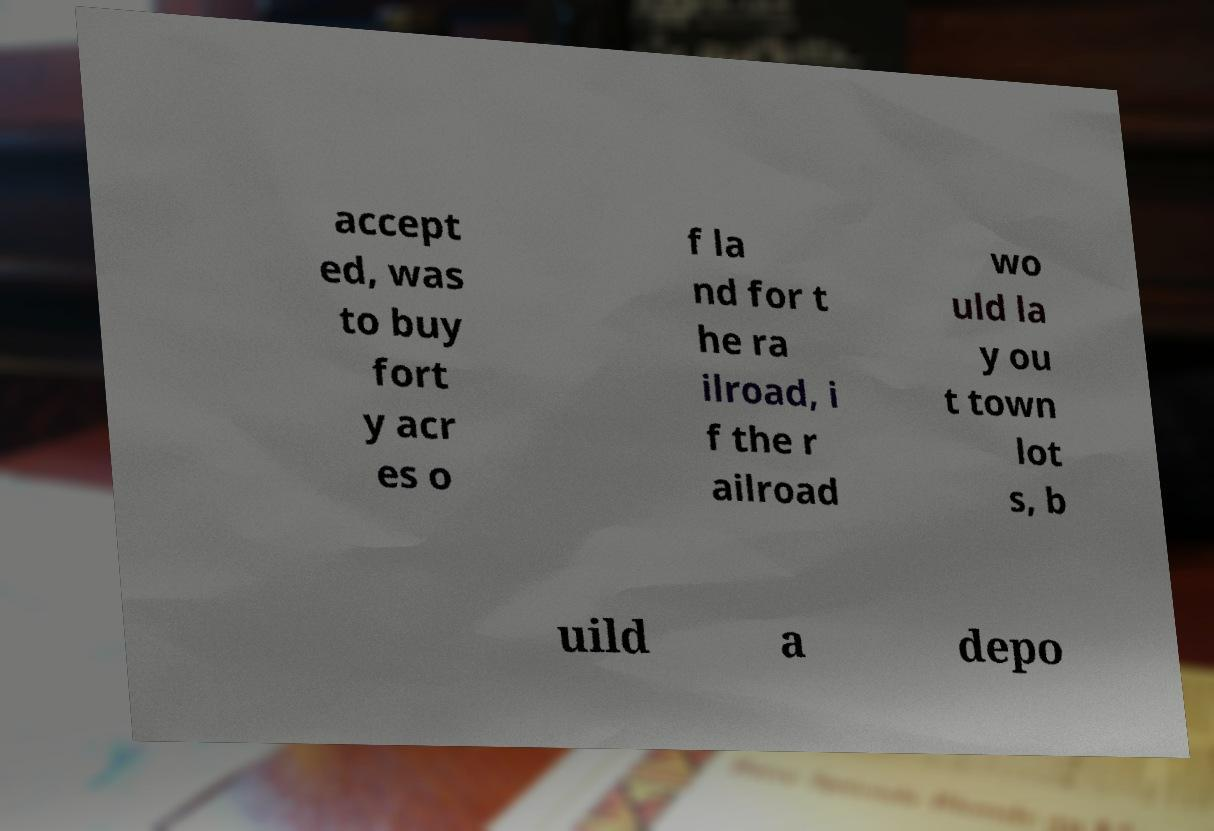There's text embedded in this image that I need extracted. Can you transcribe it verbatim? accept ed, was to buy fort y acr es o f la nd for t he ra ilroad, i f the r ailroad wo uld la y ou t town lot s, b uild a depo 